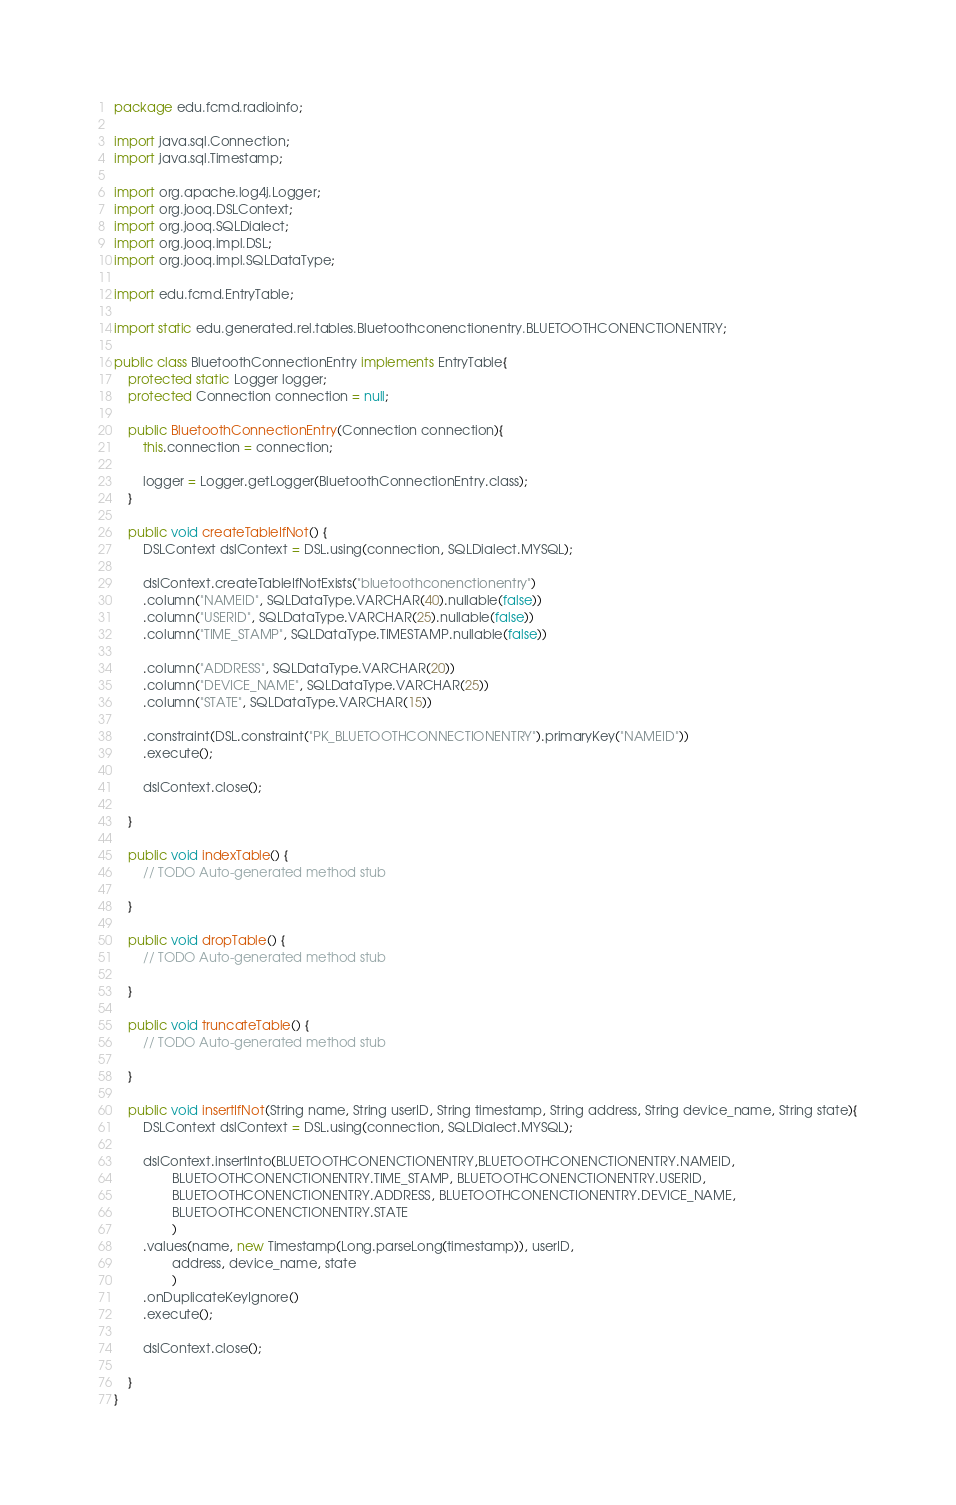Convert code to text. <code><loc_0><loc_0><loc_500><loc_500><_Java_>package edu.fcmd.radioinfo;

import java.sql.Connection;
import java.sql.Timestamp;

import org.apache.log4j.Logger;
import org.jooq.DSLContext;
import org.jooq.SQLDialect;
import org.jooq.impl.DSL;
import org.jooq.impl.SQLDataType;

import edu.fcmd.EntryTable;

import static edu.generated.rel.tables.Bluetoothconenctionentry.BLUETOOTHCONENCTIONENTRY;

public class BluetoothConnectionEntry implements EntryTable{
	protected static Logger logger;
	protected Connection connection = null;

	public BluetoothConnectionEntry(Connection connection){
		this.connection = connection;

		logger = Logger.getLogger(BluetoothConnectionEntry.class);
	}
	
	public void createTableIfNot() {
		DSLContext dslContext = DSL.using(connection, SQLDialect.MYSQL);

		dslContext.createTableIfNotExists("bluetoothconenctionentry")
		.column("NAMEID", SQLDataType.VARCHAR(40).nullable(false))
		.column("USERID", SQLDataType.VARCHAR(25).nullable(false))
		.column("TIME_STAMP", SQLDataType.TIMESTAMP.nullable(false))
		
		.column("ADDRESS", SQLDataType.VARCHAR(20))
		.column("DEVICE_NAME", SQLDataType.VARCHAR(25))
		.column("STATE", SQLDataType.VARCHAR(15))
		
		.constraint(DSL.constraint("PK_BLUETOOTHCONNECTIONENTRY").primaryKey("NAMEID"))
		.execute();

		dslContext.close();

	}

	public void indexTable() {
		// TODO Auto-generated method stub

	}

	public void dropTable() {
		// TODO Auto-generated method stub

	}

	public void truncateTable() {
		// TODO Auto-generated method stub

	}

	public void insertIfNot(String name, String userID, String timestamp, String address, String device_name, String state){
		DSLContext dslContext = DSL.using(connection, SQLDialect.MYSQL);

		dslContext.insertInto(BLUETOOTHCONENCTIONENTRY,BLUETOOTHCONENCTIONENTRY.NAMEID,
				BLUETOOTHCONENCTIONENTRY.TIME_STAMP, BLUETOOTHCONENCTIONENTRY.USERID,
				BLUETOOTHCONENCTIONENTRY.ADDRESS, BLUETOOTHCONENCTIONENTRY.DEVICE_NAME,
				BLUETOOTHCONENCTIONENTRY.STATE
				)
		.values(name, new Timestamp(Long.parseLong(timestamp)), userID, 
				address, device_name, state
				)
		.onDuplicateKeyIgnore()
		.execute();

		dslContext.close();

	}
}
</code> 